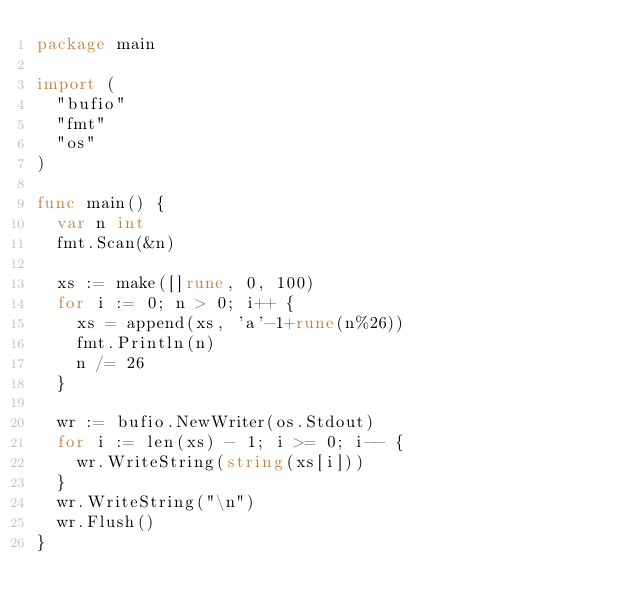<code> <loc_0><loc_0><loc_500><loc_500><_Go_>package main

import (
	"bufio"
	"fmt"
	"os"
)

func main() {
	var n int
	fmt.Scan(&n)

	xs := make([]rune, 0, 100)
	for i := 0; n > 0; i++ {
		xs = append(xs, 'a'-1+rune(n%26))
		fmt.Println(n)
		n /= 26
	}

	wr := bufio.NewWriter(os.Stdout)
	for i := len(xs) - 1; i >= 0; i-- {
		wr.WriteString(string(xs[i]))
	}
	wr.WriteString("\n")
	wr.Flush()
}
</code> 